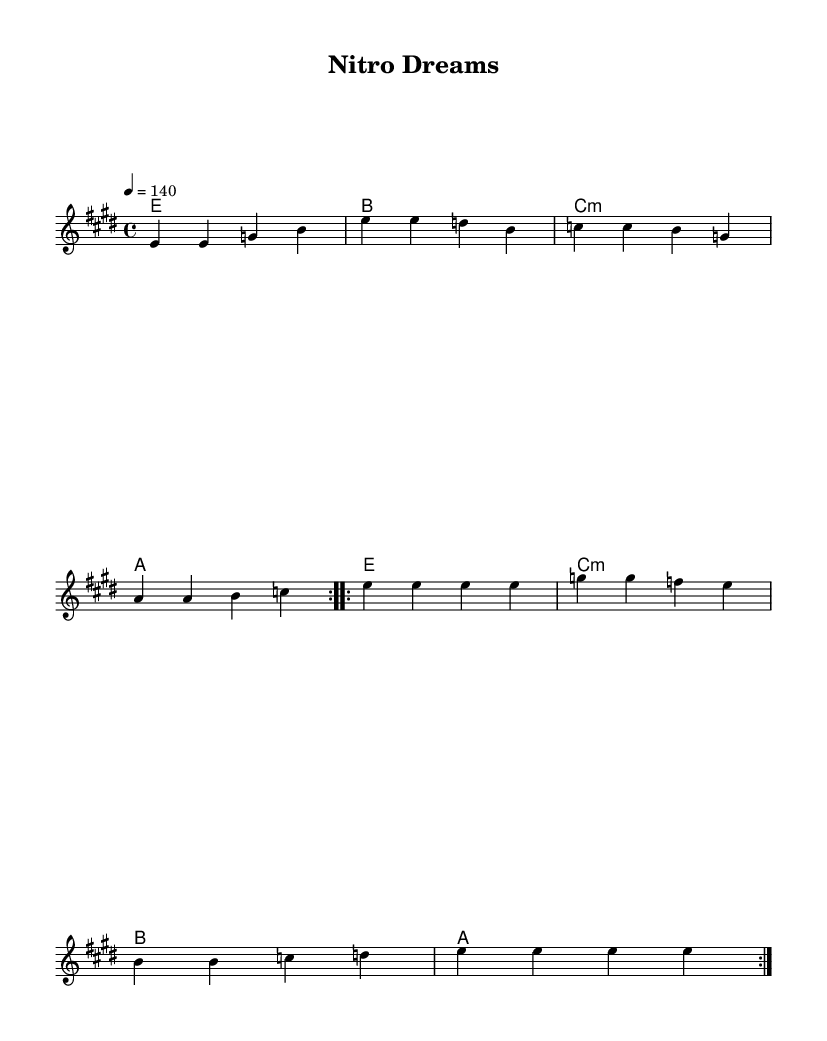What is the key signature of this music? The key signature for the piece is E major, which contains four sharps: F#, C#, G#, and D#. This can be identified from the key indicated at the beginning of the score.
Answer: E major What is the time signature of this music? The time signature is written as 4/4, which is indicated at the start of the score. This means there are four beats in each measure, and a quarter note gets one beat.
Answer: 4/4 What is the tempo marking of this piece? The tempo marking is indicated as "4 = 140," which specifies that the quarter note is played at 140 beats per minute. This indicates a fast tempo typical of pop-rock anthems.
Answer: 140 How many measures are there in the first section of the melody? The first section of the melody consists of eight measures, as described in the repeated volta commands. Each volta indicates that the section should be played twice.
Answer: 8 What is the root chord of the first measure? The first measure contains the E major chord, which is identified by the root note 'E.' This chord is located in the harmonies section of the score.
Answer: E How does the melody change in the second section? In the second section, the melody features a different rhythm, with a repetitive emphasis on the note 'e,' showcasing a continuation of energy and momentum, typical of high-energy pop-rock.
Answer: Repetitive 'e' notes What is the function of the C minor chord in the harmonies? The C minor chord serves as a tonic in the second half of the progression, providing a contrast to the E major and creating a dynamic tension that is often resolved back to E major. This can be inferred from its placement in the harmony structure.
Answer: Tonic 